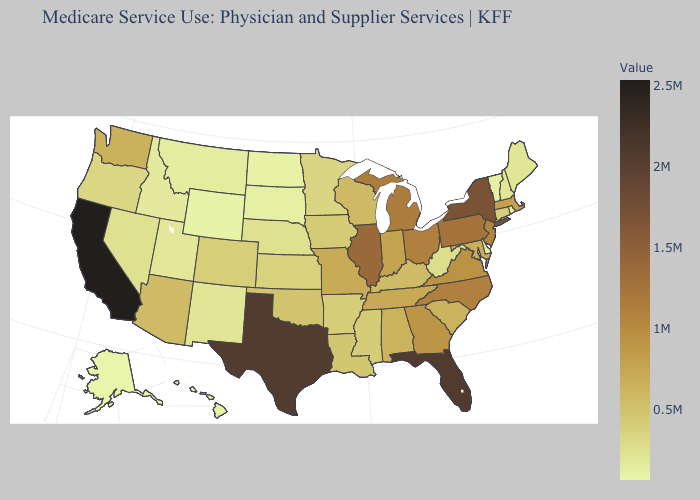Does Florida have the highest value in the South?
Be succinct. Yes. Which states have the lowest value in the USA?
Keep it brief. Alaska. Does Missouri have a lower value than Arkansas?
Concise answer only. No. Which states have the lowest value in the Northeast?
Be succinct. Rhode Island. Among the states that border Oregon , which have the lowest value?
Answer briefly. Idaho. Among the states that border Georgia , which have the lowest value?
Short answer required. Alabama. Which states hav the highest value in the South?
Quick response, please. Florida. Which states have the lowest value in the MidWest?
Write a very short answer. North Dakota. 